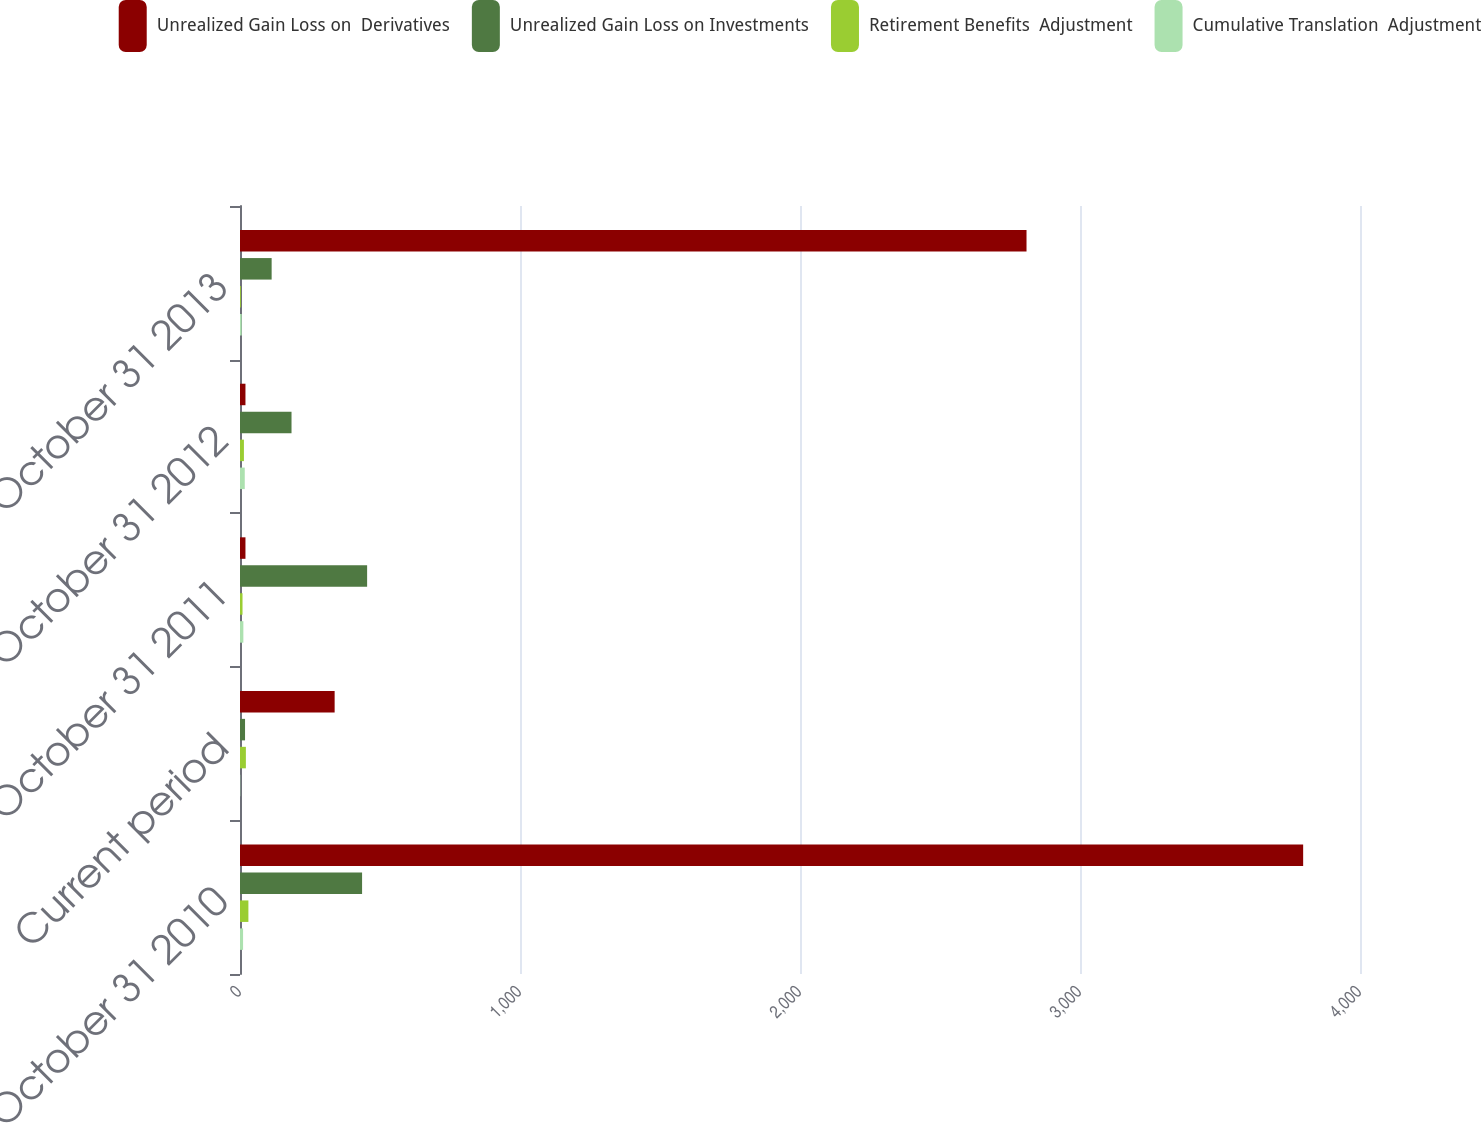Convert chart. <chart><loc_0><loc_0><loc_500><loc_500><stacked_bar_chart><ecel><fcel>October 31 2010<fcel>Current period<fcel>October 31 2011<fcel>October 31 2012<fcel>October 31 2013<nl><fcel>Unrealized Gain Loss on  Derivatives<fcel>3797<fcel>338<fcel>19.5<fcel>19.5<fcel>2809<nl><fcel>Unrealized Gain Loss on Investments<fcel>436<fcel>18<fcel>454<fcel>184<fcel>113<nl><fcel>Retirement Benefits  Adjustment<fcel>30<fcel>21<fcel>9<fcel>14<fcel>3<nl><fcel>Cumulative Translation  Adjustment<fcel>11<fcel>1<fcel>12<fcel>17<fcel>6<nl></chart> 